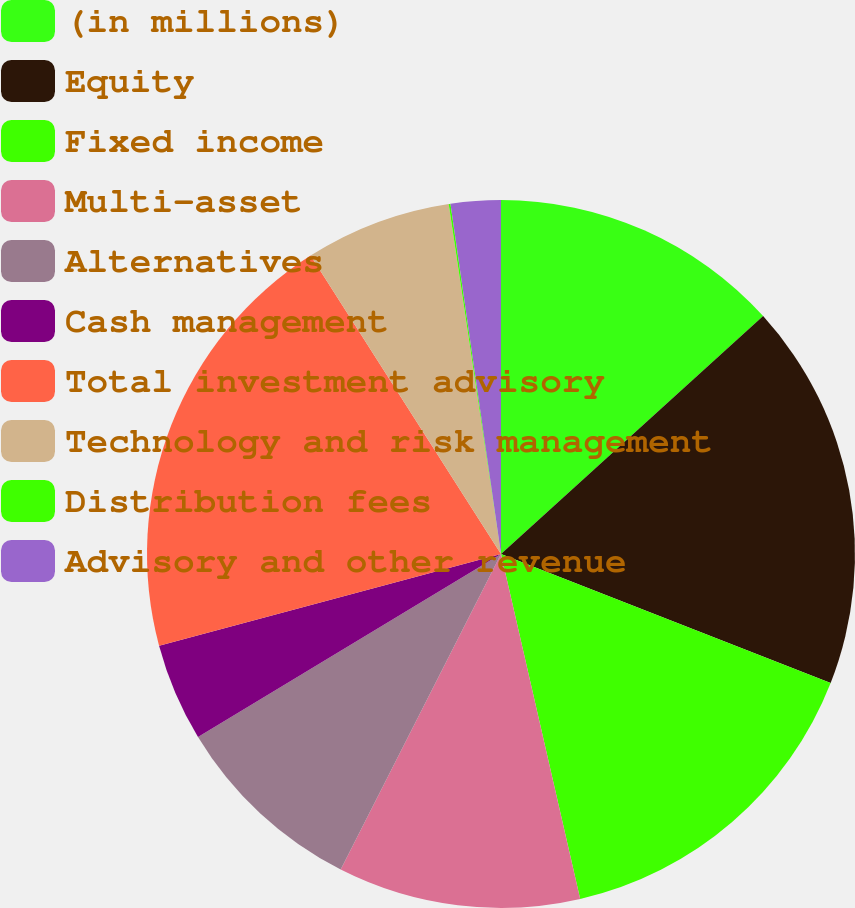<chart> <loc_0><loc_0><loc_500><loc_500><pie_chart><fcel>(in millions)<fcel>Equity<fcel>Fixed income<fcel>Multi-asset<fcel>Alternatives<fcel>Cash management<fcel>Total investment advisory<fcel>Technology and risk management<fcel>Distribution fees<fcel>Advisory and other revenue<nl><fcel>13.27%<fcel>17.67%<fcel>15.47%<fcel>11.07%<fcel>8.87%<fcel>4.48%<fcel>20.13%<fcel>6.68%<fcel>0.08%<fcel>2.28%<nl></chart> 